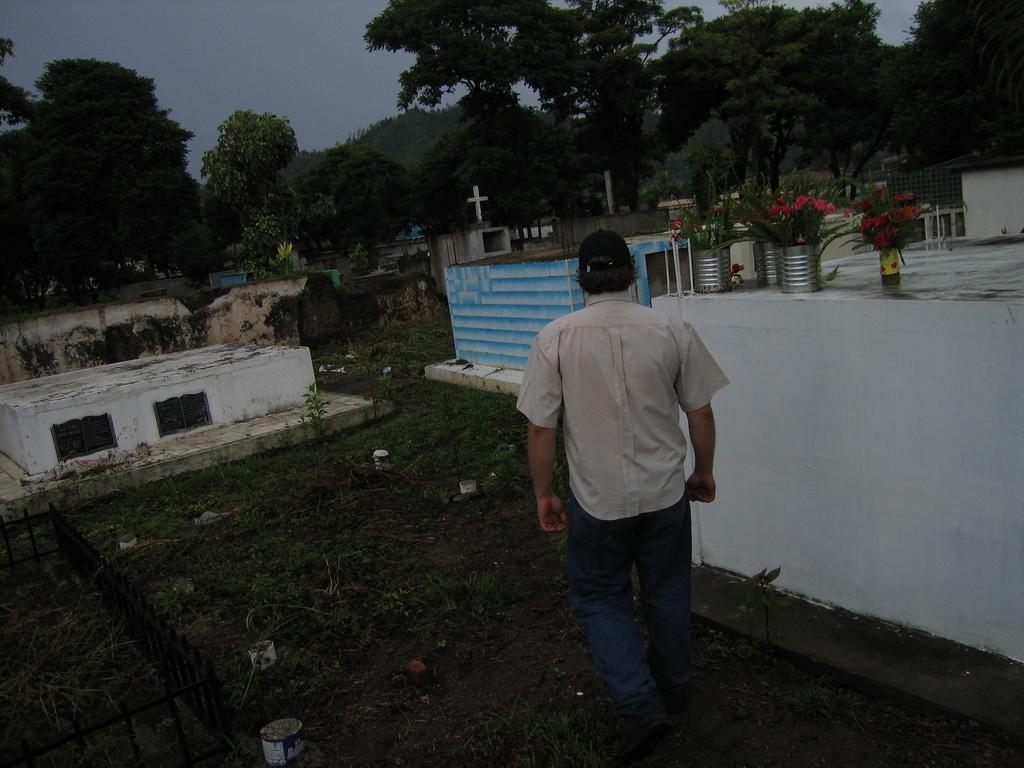In one or two sentences, can you explain what this image depicts? In this image there is a man, walking on a graveyard, around him there are graves, in the background there are trees and the sky. 